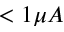Convert formula to latex. <formula><loc_0><loc_0><loc_500><loc_500>< 1 \mu A</formula> 